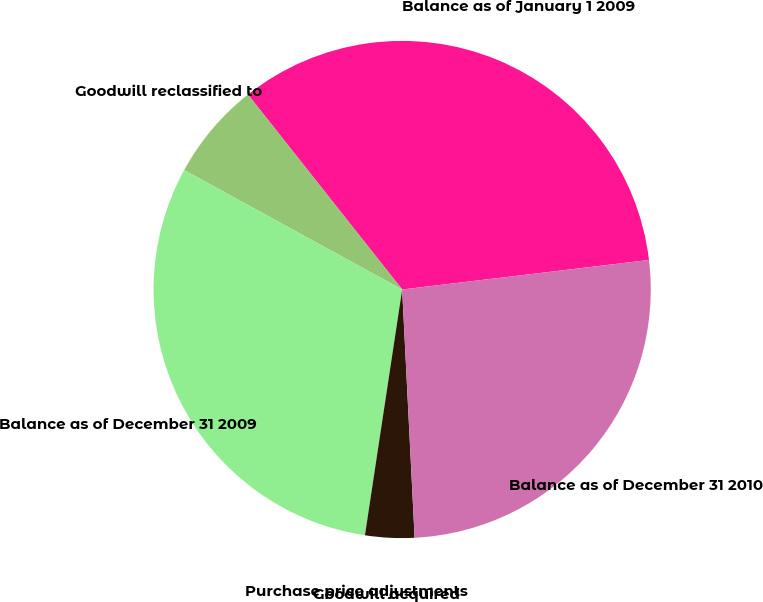Convert chart to OTSL. <chart><loc_0><loc_0><loc_500><loc_500><pie_chart><fcel>Balance as of January 1 2009<fcel>Goodwill reclassified to<fcel>Balance as of December 31 2009<fcel>Purchase price adjustments<fcel>Goodwill acquired<fcel>Balance as of December 31 2010<nl><fcel>33.76%<fcel>6.37%<fcel>30.58%<fcel>0.01%<fcel>3.19%<fcel>26.1%<nl></chart> 